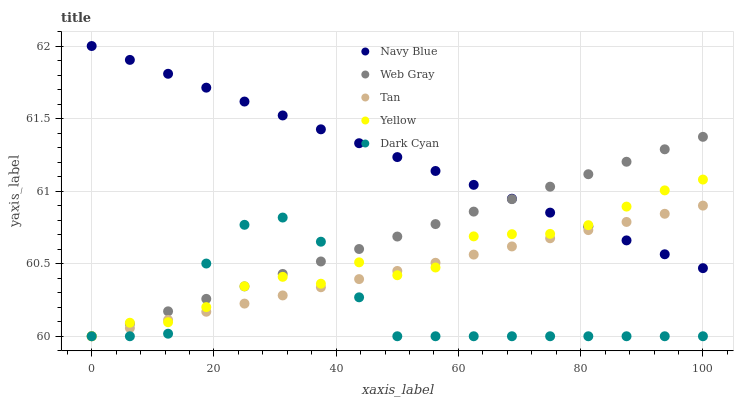Does Dark Cyan have the minimum area under the curve?
Answer yes or no. Yes. Does Navy Blue have the maximum area under the curve?
Answer yes or no. Yes. Does Tan have the minimum area under the curve?
Answer yes or no. No. Does Tan have the maximum area under the curve?
Answer yes or no. No. Is Tan the smoothest?
Answer yes or no. Yes. Is Dark Cyan the roughest?
Answer yes or no. Yes. Is Navy Blue the smoothest?
Answer yes or no. No. Is Navy Blue the roughest?
Answer yes or no. No. Does Dark Cyan have the lowest value?
Answer yes or no. Yes. Does Navy Blue have the lowest value?
Answer yes or no. No. Does Navy Blue have the highest value?
Answer yes or no. Yes. Does Tan have the highest value?
Answer yes or no. No. Is Dark Cyan less than Navy Blue?
Answer yes or no. Yes. Is Navy Blue greater than Dark Cyan?
Answer yes or no. Yes. Does Dark Cyan intersect Tan?
Answer yes or no. Yes. Is Dark Cyan less than Tan?
Answer yes or no. No. Is Dark Cyan greater than Tan?
Answer yes or no. No. Does Dark Cyan intersect Navy Blue?
Answer yes or no. No. 